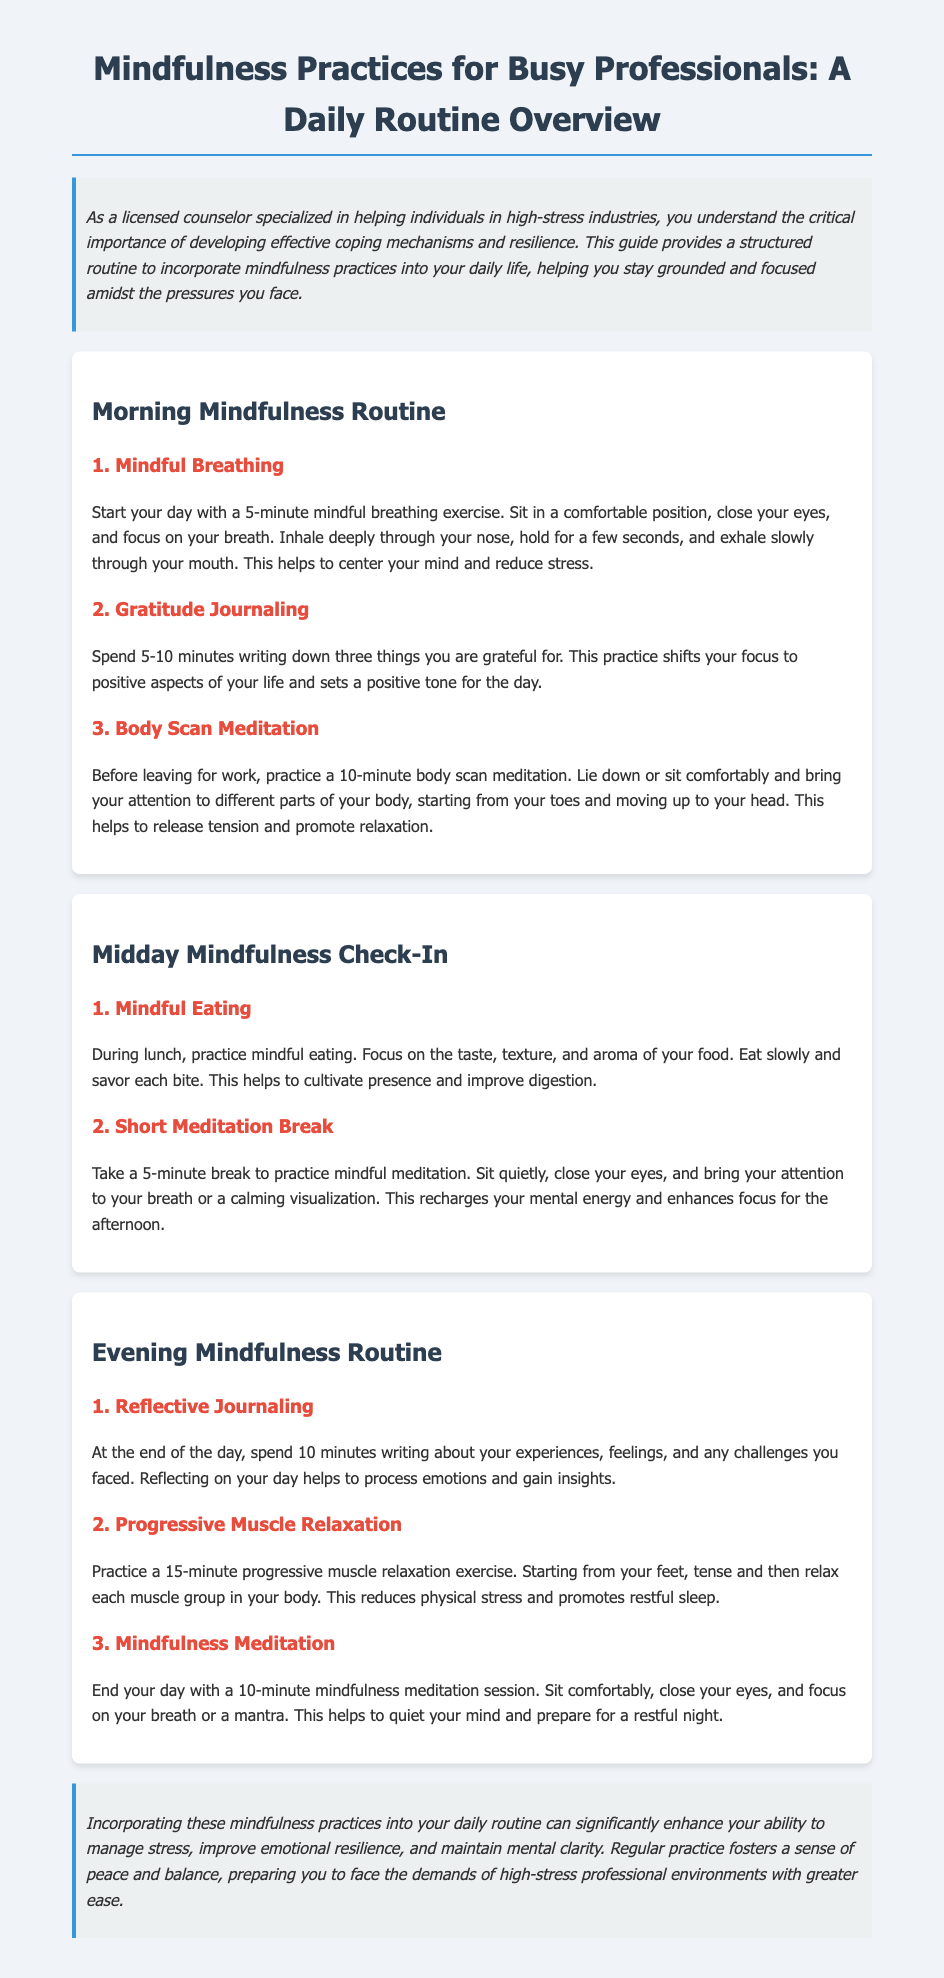What is the title of the document? The title of the document is provided at the beginning and summarizes the content being covered, which is mindfulness practices for busy professionals.
Answer: Mindfulness Practices for Busy Professionals: A Daily Routine Overview How long should the mindful breathing exercise last? The document specifies that the mindful breathing exercise should be conducted for a duration of 5 minutes.
Answer: 5 minutes What is one practice suggested for the morning routine? The document outlines several practices in the morning routine, of which mindful breathing is one.
Answer: Mindful Breathing What is the focus of the midday mindful eating practice? The midday practice emphasizes being present and aware during the act of eating, focusing on taste, texture, and aroma.
Answer: Taste, texture, and aroma How long should the evening mindfulness meditation session last? The document states that the mindfulness meditation session at the end of the day should last for 10 minutes.
Answer: 10 minutes What is the ultimate benefit of incorporating mindfulness practices according to the conclusion? The conclusion highlights that regular practice fosters a sense of peace and balance, enhancing the ability to manage stress.
Answer: Manage stress What type of exercise is suggested for reducing physical stress in the evening routine? The document suggests progressive muscle relaxation as an effective exercise to reduce physical stress.
Answer: Progressive Muscle Relaxation 